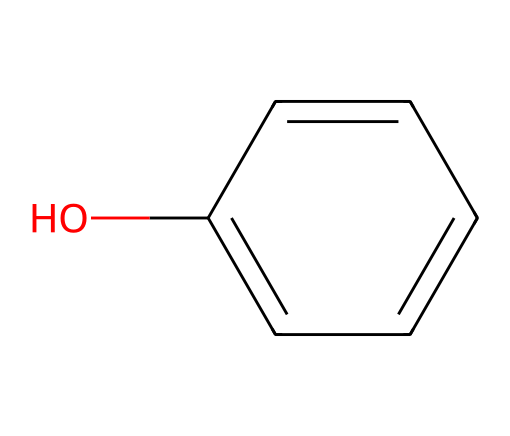What is the molecular formula of phenol? The SMILES representation indicates the structure has six carbon atoms, six hydrogen atoms, and one oxygen atom. The molecular formula is calculated by identifying the types and counts of atoms present.
Answer: C6H6O How many aromatic rings are present in this structure? The provided SMILES notation has a benzene ring, which is characteristic of aromatic compounds. Since phenol has one benzene ring in its structure, the answer is straightforward.
Answer: 1 What type of functional group is present in phenol? By analyzing the SMILES representation, the hydroxyl group (-OH) attached directly to the aromatic ring indicates the presence of a functional group specific to phenols.
Answer: hydroxyl What is the total number of hydrogen atoms directly bonded to the carbon atoms in the structure? The structure includes one aromatic ring (benzene) with five hydrogen atoms because one hydrogen is replaced by the hydroxyl group. Therefore, the count is five hydrogen atoms in the aromatic part of the structure.
Answer: 5 How does the presence of the hydroxyl group affect the solubility of phenol in water? The hydroxyl group increases the polarity of phenol, allowing it to form hydrogen bonds with water molecules. This interaction leads to enhanced solubility in polar solvents like water.
Answer: increases Is phenol considered a strong or weak acid? The hydroxyl group can donate a proton (H+), allowing phenol to act as an acid, albeit weakly. Comparing its dissociation with stronger acids confirms that it is a weak acid.
Answer: weak What role does the phenol structure play in interstellar chemistry? Phenol can act as a precursor to more complex organic molecules, contributing to the formation of various compounds detected in interstellar dust clouds, thus playing a significant role in astrochemistry.
Answer: precursor 